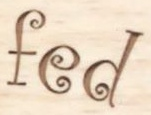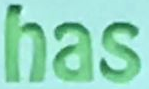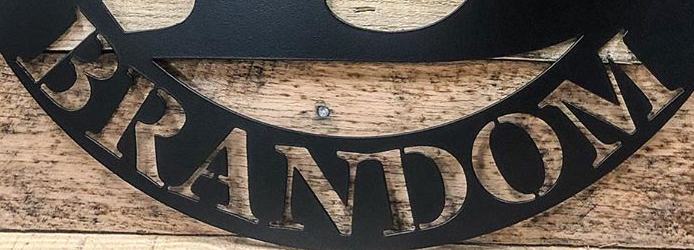Identify the words shown in these images in order, separated by a semicolon. fed; has; BRANDOM 